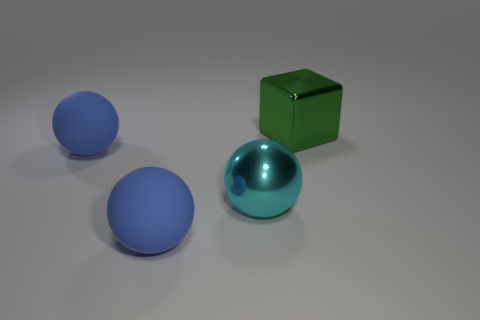Does the green object have the same shape as the cyan metal thing?
Ensure brevity in your answer.  No. What number of big things are red cylinders or balls?
Provide a succinct answer. 3. Are there any cyan objects in front of the big cyan sphere?
Give a very brief answer. No. Is the number of green shiny things to the right of the green block the same as the number of tiny cyan matte spheres?
Provide a short and direct response. Yes. There is a cyan shiny object; does it have the same shape as the large thing that is in front of the cyan shiny object?
Provide a succinct answer. Yes. There is a object behind the large ball that is behind the cyan sphere; what size is it?
Keep it short and to the point. Large. Are there the same number of blue matte objects on the right side of the cyan object and objects that are left of the green thing?
Your answer should be compact. No. Is the shape of the rubber object in front of the cyan object the same as  the big cyan metal thing?
Your answer should be very brief. Yes. What is the shape of the big metal object that is in front of the shiny thing that is right of the large metal object that is in front of the big cube?
Provide a short and direct response. Sphere. The cyan thing is what size?
Provide a succinct answer. Large. 